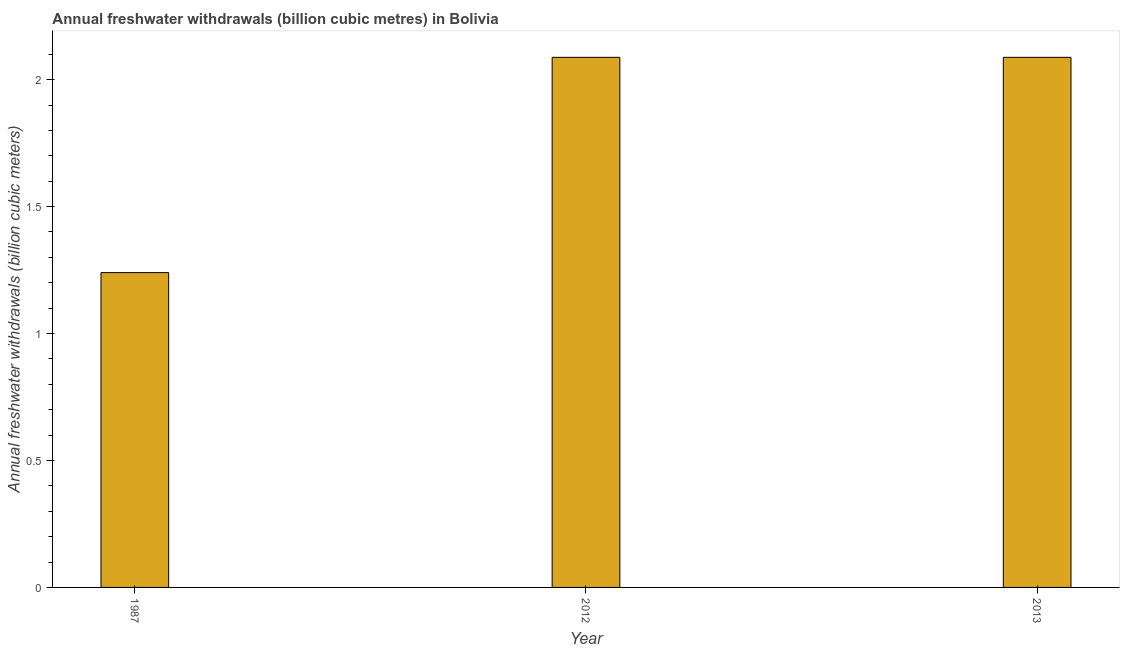Does the graph contain any zero values?
Make the answer very short. No. Does the graph contain grids?
Offer a terse response. No. What is the title of the graph?
Provide a succinct answer. Annual freshwater withdrawals (billion cubic metres) in Bolivia. What is the label or title of the X-axis?
Offer a terse response. Year. What is the label or title of the Y-axis?
Your answer should be compact. Annual freshwater withdrawals (billion cubic meters). What is the annual freshwater withdrawals in 2012?
Your answer should be very brief. 2.09. Across all years, what is the maximum annual freshwater withdrawals?
Offer a terse response. 2.09. Across all years, what is the minimum annual freshwater withdrawals?
Your answer should be compact. 1.24. In which year was the annual freshwater withdrawals maximum?
Make the answer very short. 2012. In which year was the annual freshwater withdrawals minimum?
Keep it short and to the point. 1987. What is the sum of the annual freshwater withdrawals?
Offer a very short reply. 5.42. What is the difference between the annual freshwater withdrawals in 1987 and 2012?
Provide a short and direct response. -0.85. What is the average annual freshwater withdrawals per year?
Make the answer very short. 1.8. What is the median annual freshwater withdrawals?
Provide a short and direct response. 2.09. In how many years, is the annual freshwater withdrawals greater than 1.1 billion cubic meters?
Provide a short and direct response. 3. Do a majority of the years between 1987 and 2012 (inclusive) have annual freshwater withdrawals greater than 1.7 billion cubic meters?
Make the answer very short. No. What is the ratio of the annual freshwater withdrawals in 1987 to that in 2013?
Ensure brevity in your answer.  0.59. Is the annual freshwater withdrawals in 2012 less than that in 2013?
Provide a succinct answer. No. What is the difference between the highest and the lowest annual freshwater withdrawals?
Give a very brief answer. 0.85. In how many years, is the annual freshwater withdrawals greater than the average annual freshwater withdrawals taken over all years?
Keep it short and to the point. 2. How many bars are there?
Your answer should be compact. 3. How many years are there in the graph?
Ensure brevity in your answer.  3. What is the difference between two consecutive major ticks on the Y-axis?
Your answer should be compact. 0.5. What is the Annual freshwater withdrawals (billion cubic meters) of 1987?
Provide a succinct answer. 1.24. What is the Annual freshwater withdrawals (billion cubic meters) of 2012?
Your answer should be compact. 2.09. What is the Annual freshwater withdrawals (billion cubic meters) of 2013?
Offer a terse response. 2.09. What is the difference between the Annual freshwater withdrawals (billion cubic meters) in 1987 and 2012?
Offer a very short reply. -0.85. What is the difference between the Annual freshwater withdrawals (billion cubic meters) in 1987 and 2013?
Your answer should be very brief. -0.85. What is the ratio of the Annual freshwater withdrawals (billion cubic meters) in 1987 to that in 2012?
Offer a very short reply. 0.59. What is the ratio of the Annual freshwater withdrawals (billion cubic meters) in 1987 to that in 2013?
Provide a short and direct response. 0.59. 